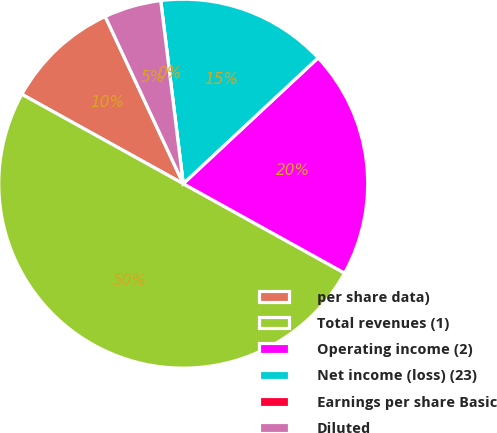Convert chart to OTSL. <chart><loc_0><loc_0><loc_500><loc_500><pie_chart><fcel>per share data)<fcel>Total revenues (1)<fcel>Operating income (2)<fcel>Net income (loss) (23)<fcel>Earnings per share Basic<fcel>Diluted<nl><fcel>10.0%<fcel>50.0%<fcel>20.0%<fcel>15.0%<fcel>0.0%<fcel>5.0%<nl></chart> 